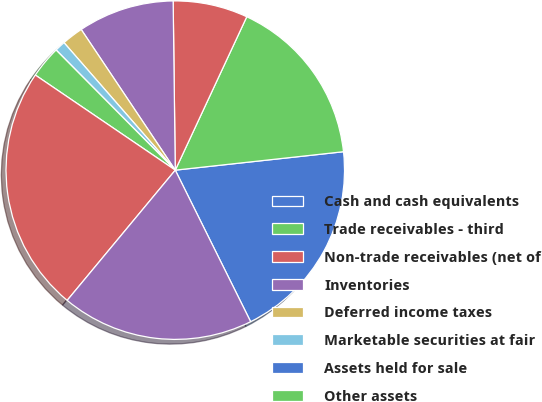<chart> <loc_0><loc_0><loc_500><loc_500><pie_chart><fcel>Cash and cash equivalents<fcel>Trade receivables - third<fcel>Non-trade receivables (net of<fcel>Inventories<fcel>Deferred income taxes<fcel>Marketable securities at fair<fcel>Assets held for sale<fcel>Other assets<fcel>Total current assets<fcel>Investments in affiliates<nl><fcel>19.39%<fcel>16.32%<fcel>7.14%<fcel>9.18%<fcel>2.04%<fcel>1.02%<fcel>0.0%<fcel>3.06%<fcel>23.47%<fcel>18.37%<nl></chart> 